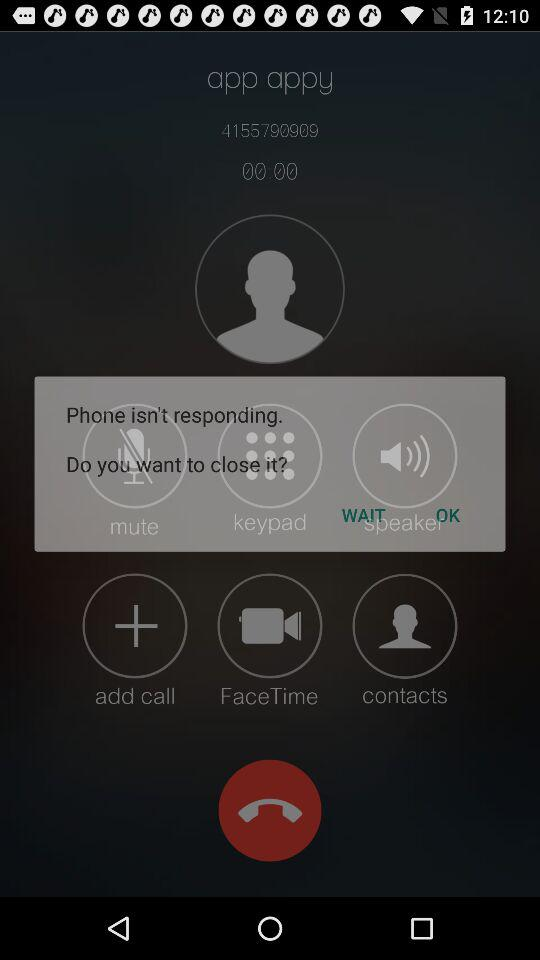What is the application name? The application name is "2GIS Dialer". 